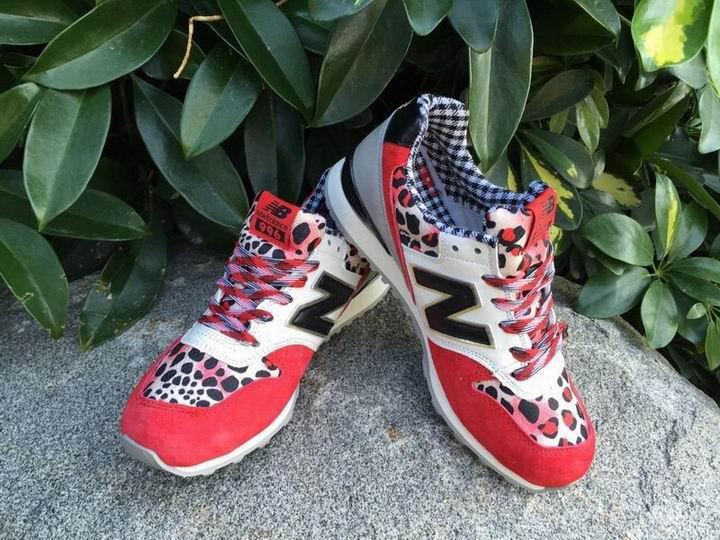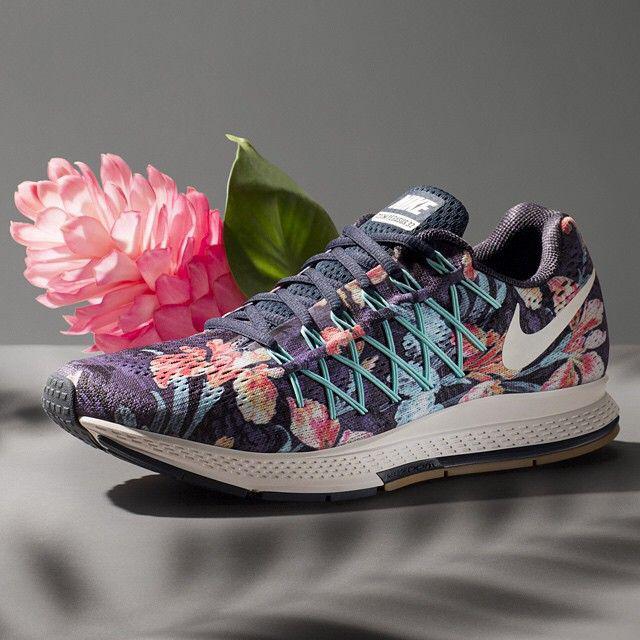The first image is the image on the left, the second image is the image on the right. Considering the images on both sides, is "The image on the right in the pair has fewer than five sneakers." valid? Answer yes or no. Yes. The first image is the image on the left, the second image is the image on the right. Evaluate the accuracy of this statement regarding the images: "In the image on the left, a red and yellow shoe is sitting on the right side of the row.". Is it true? Answer yes or no. No. 